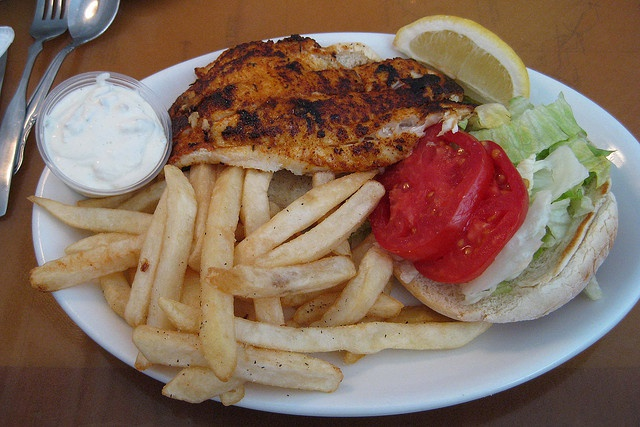Describe the objects in this image and their specific colors. I can see dining table in darkgray, maroon, tan, and brown tones, sandwich in black, brown, darkgray, olive, and maroon tones, sandwich in black, maroon, brown, and gray tones, pizza in black, maroon, brown, and gray tones, and bowl in black, lightgray, and darkgray tones in this image. 